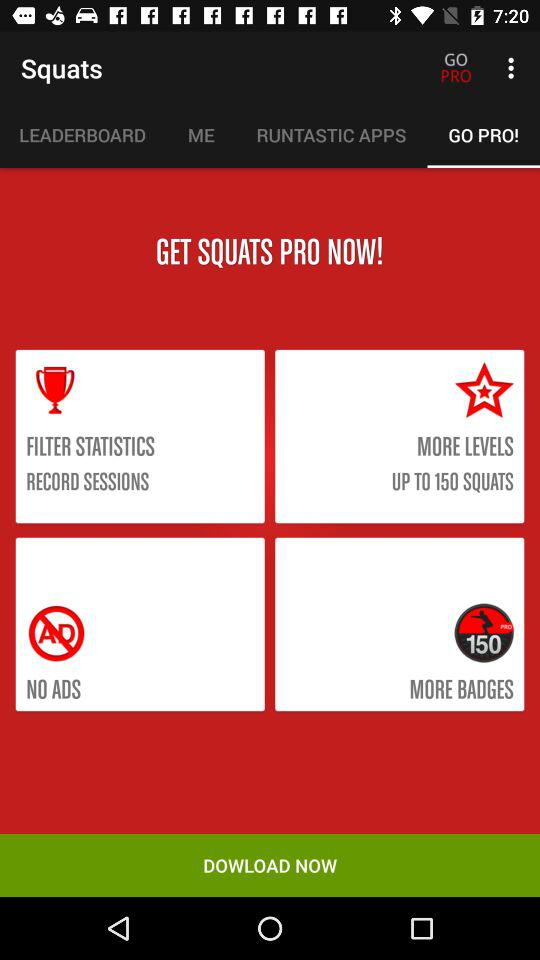How many more badges are available in the pro version than the free version?
Answer the question using a single word or phrase. 150 